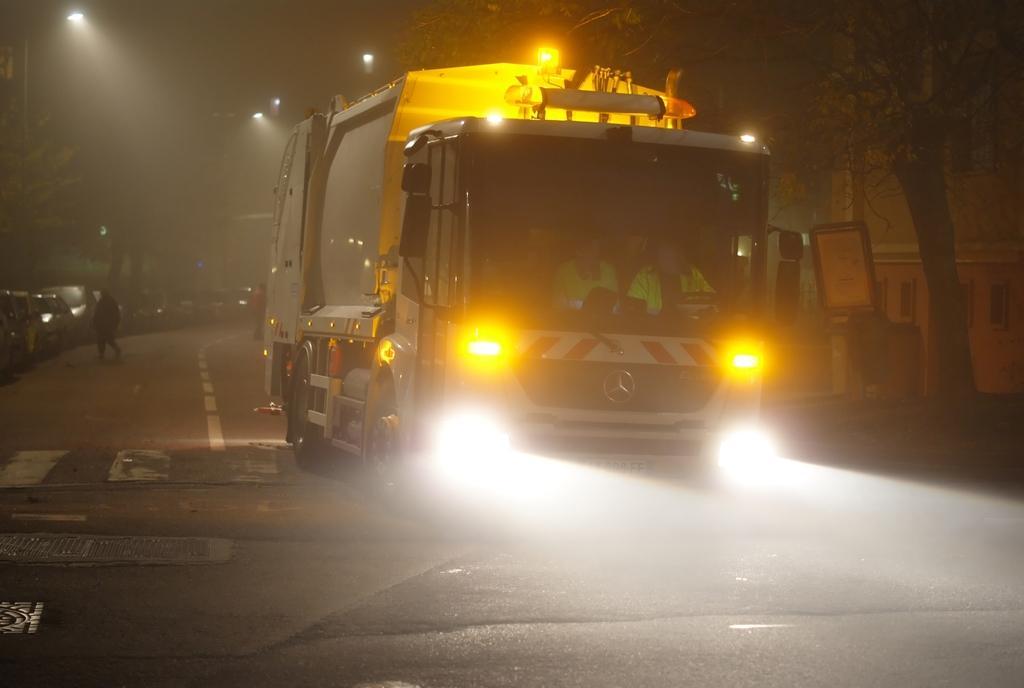Could you give a brief overview of what you see in this image? In this picture I can observe a lorry. There are some people sitting in the lorry. I can observe yellow and white color lights fixed to the lorry. On the left side I can observe some cars parked on the road. The background is dark. 